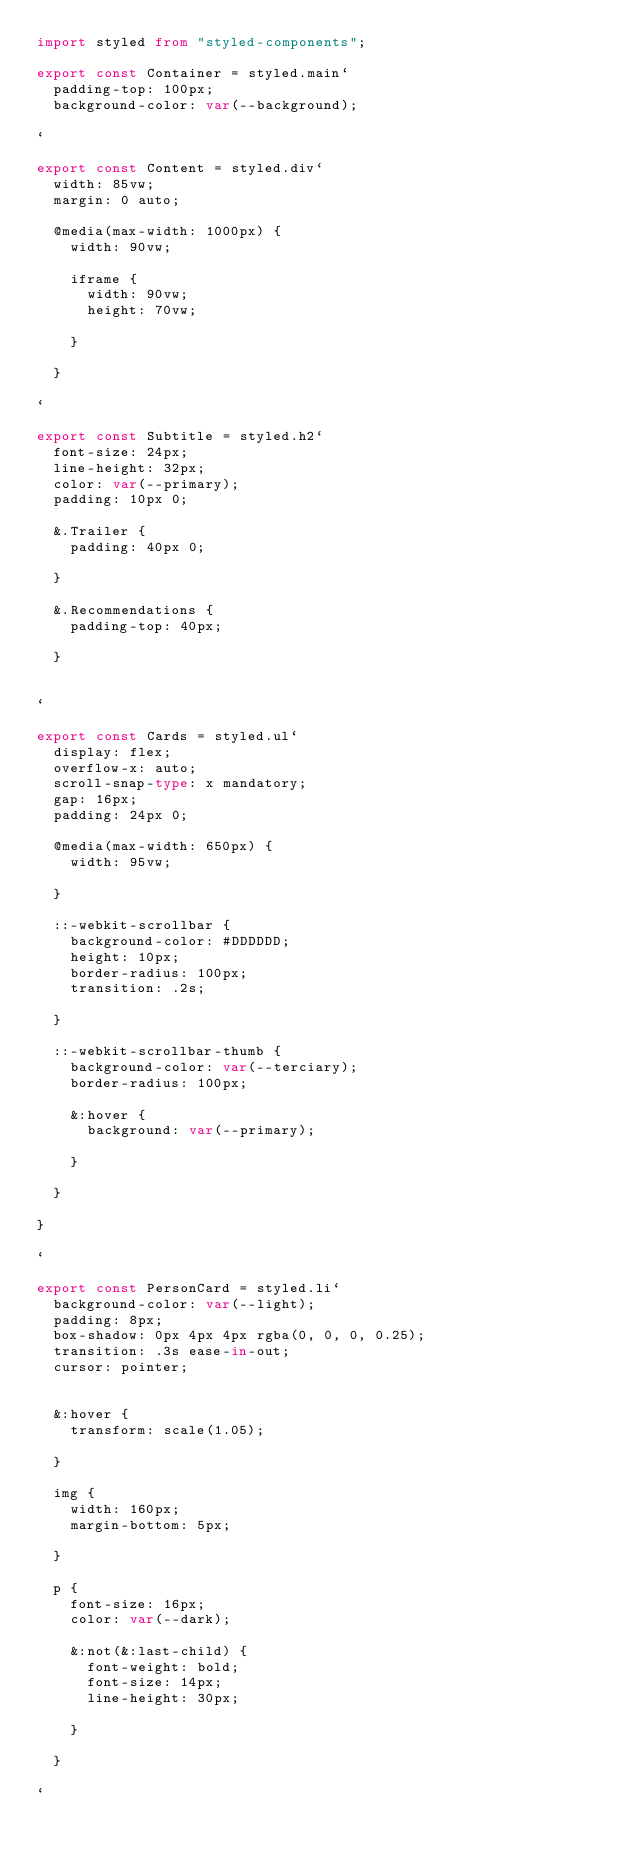Convert code to text. <code><loc_0><loc_0><loc_500><loc_500><_TypeScript_>import styled from "styled-components";

export const Container = styled.main`
  padding-top: 100px;
  background-color: var(--background);

`

export const Content = styled.div`
  width: 85vw;
  margin: 0 auto;

  @media(max-width: 1000px) {
    width: 90vw;

    iframe {
      width: 90vw;
      height: 70vw;

    }

  }

`

export const Subtitle = styled.h2`
  font-size: 24px;
  line-height: 32px;
  color: var(--primary);
  padding: 10px 0;

  &.Trailer {
    padding: 40px 0;

  }

  &.Recommendations {
    padding-top: 40px;

  }


`

export const Cards = styled.ul`
  display: flex;
  overflow-x: auto;
  scroll-snap-type: x mandatory;
  gap: 16px;
  padding: 24px 0;

  @media(max-width: 650px) {
    width: 95vw;
    
  }

  ::-webkit-scrollbar {
    background-color: #DDDDDD;
    height: 10px;
    border-radius: 100px;
    transition: .2s;
    
  }

  ::-webkit-scrollbar-thumb {
    background-color: var(--terciary);
    border-radius: 100px;

    &:hover {
      background: var(--primary);
  
    }

  }

}

`

export const PersonCard = styled.li`
  background-color: var(--light);
  padding: 8px;
  box-shadow: 0px 4px 4px rgba(0, 0, 0, 0.25);
  transition: .3s ease-in-out;
  cursor: pointer;


  &:hover {
    transform: scale(1.05);

  }

  img {
    width: 160px;
    margin-bottom: 5px;
    
  }
  
  p {
    font-size: 16px;
    color: var(--dark);
    
    &:not(&:last-child) {
      font-weight: bold;
      font-size: 14px;
      line-height: 30px;

    }

  }

`</code> 